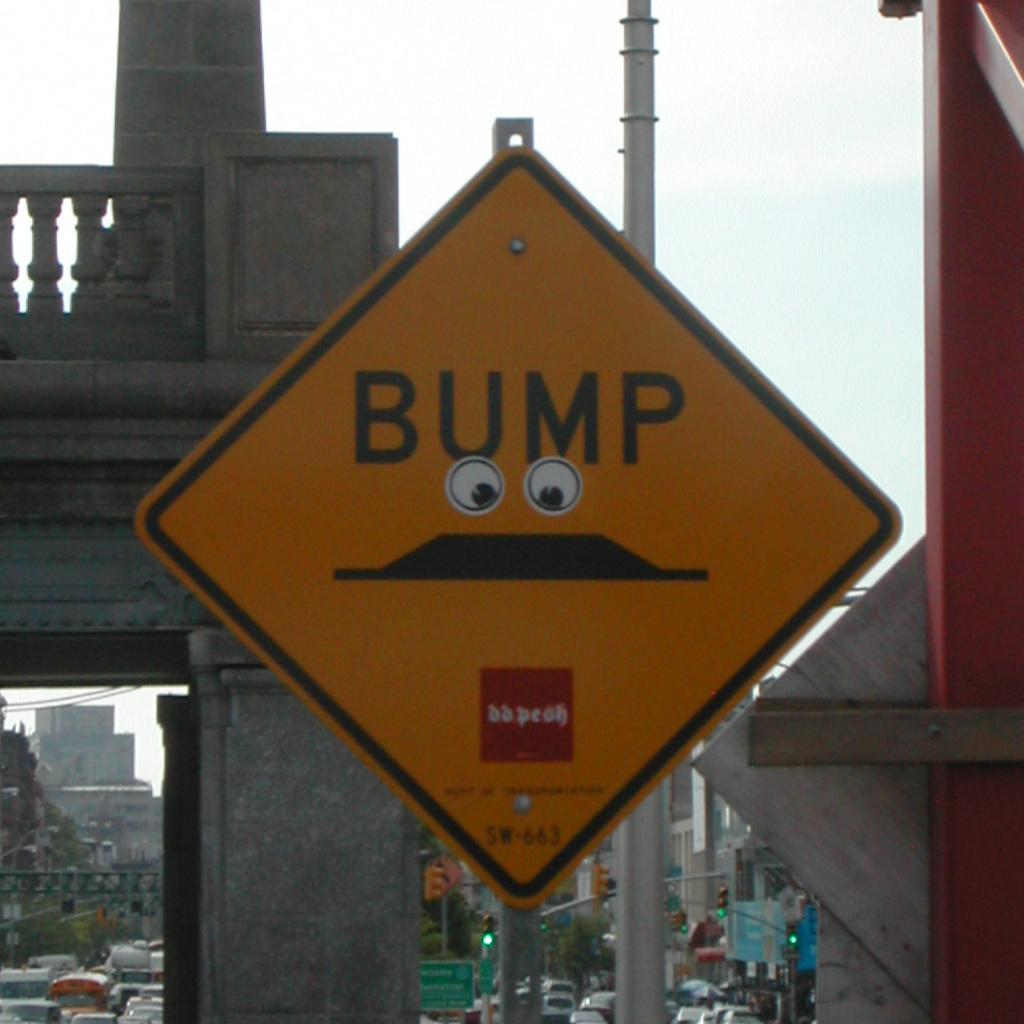<image>
Relay a brief, clear account of the picture shown. A yellow traffic sign that says "Bump" with googly eyes on it. 